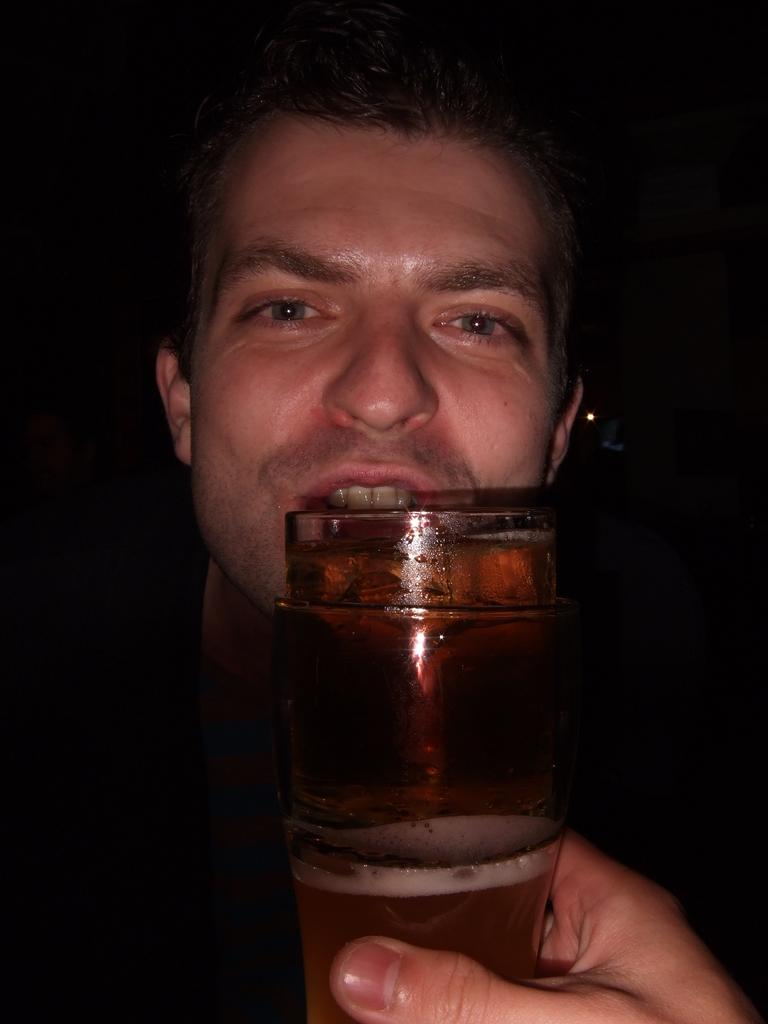Who is present in the image? There is a man in the image. What is the man doing in the image? The man is looking towards the camera. What can be seen in front of the man? There is a glass of beer in front of the man. What type of machine is being used to create winter in the image? There is no machine or winter present in the image; it features a man looking towards the camera with a glass of beer in front of him. 